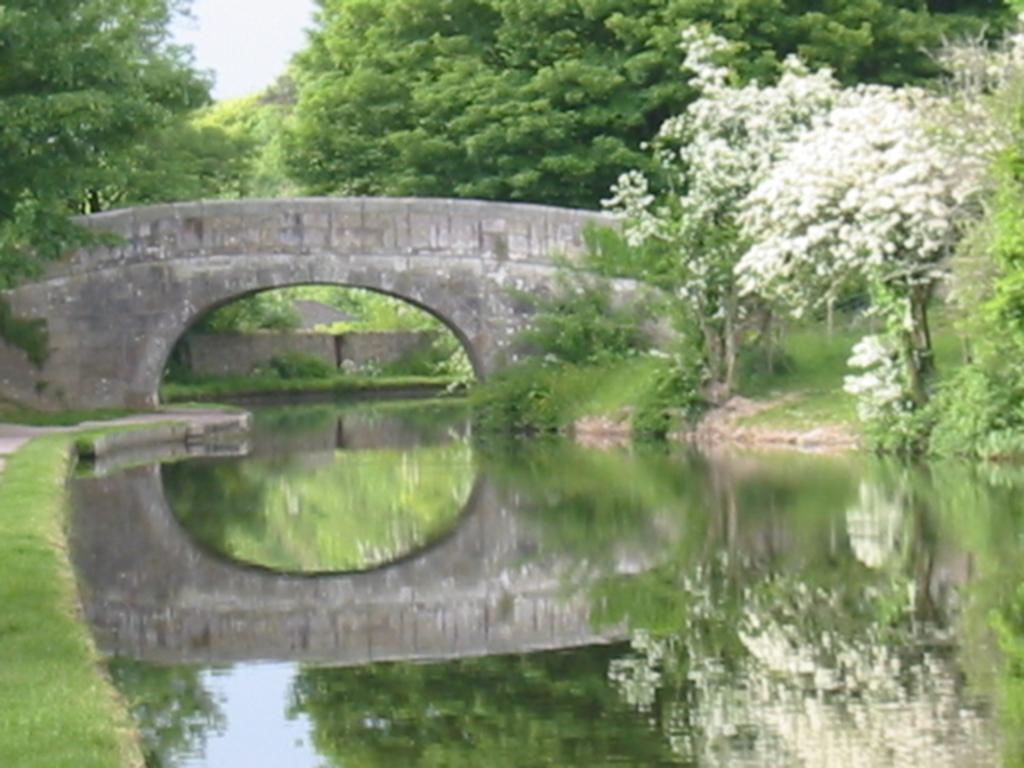What is visible in the image? Water is visible in the image. What type of flowers can be seen on the trees? White color flowers are on the trees. What can be seen in the background of the image? There is a bridge and many trees in the background of the image. What part of the natural environment is visible in the image? The sky is visible in the background of the image. What type of wood is the guide using to navigate the river in the image? There is no guide or wood present in the image; it features water, white flowers on trees, a bridge, and the sky. 